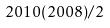<formula> <loc_0><loc_0><loc_500><loc_500>2 0 1 0 ( 2 0 0 8 ) / 2</formula> 